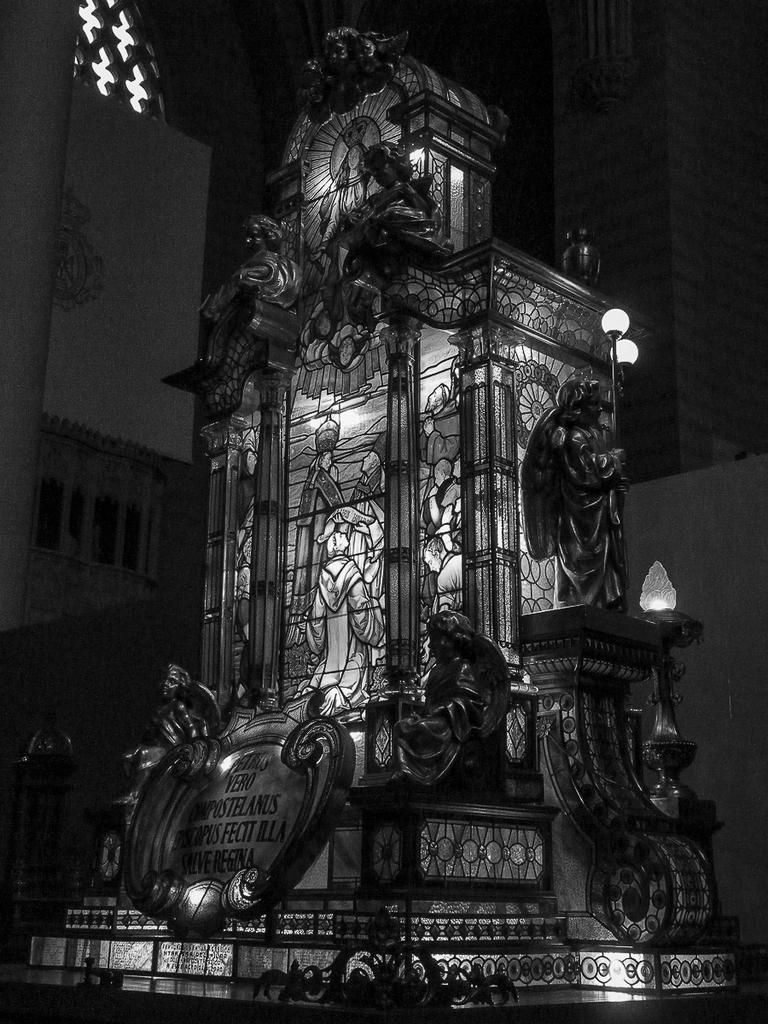What is the main subject of the image? There is a monument in the image. Where is the monument located in the image? The monument is placed in the center of the image. What is present above the monument? There are lamps above the monument. What type of cook is depicted near the monument in the image? There is no cook present in the image; it features a monument with lamps above it. How many cattle can be seen grazing near the monument in the image? There are no cattle present in the image; it features a monument with lamps above it. 